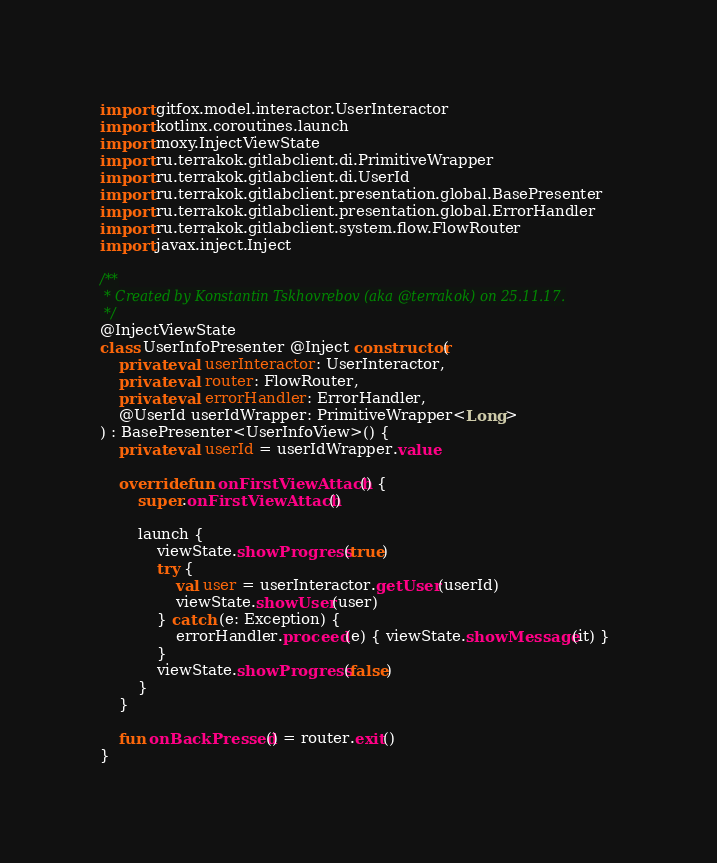<code> <loc_0><loc_0><loc_500><loc_500><_Kotlin_>
import gitfox.model.interactor.UserInteractor
import kotlinx.coroutines.launch
import moxy.InjectViewState
import ru.terrakok.gitlabclient.di.PrimitiveWrapper
import ru.terrakok.gitlabclient.di.UserId
import ru.terrakok.gitlabclient.presentation.global.BasePresenter
import ru.terrakok.gitlabclient.presentation.global.ErrorHandler
import ru.terrakok.gitlabclient.system.flow.FlowRouter
import javax.inject.Inject

/**
 * Created by Konstantin Tskhovrebov (aka @terrakok) on 25.11.17.
 */
@InjectViewState
class UserInfoPresenter @Inject constructor(
    private val userInteractor: UserInteractor,
    private val router: FlowRouter,
    private val errorHandler: ErrorHandler,
    @UserId userIdWrapper: PrimitiveWrapper<Long>
) : BasePresenter<UserInfoView>() {
    private val userId = userIdWrapper.value

    override fun onFirstViewAttach() {
        super.onFirstViewAttach()

        launch {
            viewState.showProgress(true)
            try {
                val user = userInteractor.getUser(userId)
                viewState.showUser(user)
            } catch (e: Exception) {
                errorHandler.proceed(e) { viewState.showMessage(it) }
            }
            viewState.showProgress(false)
        }
    }

    fun onBackPressed() = router.exit()
}
</code> 